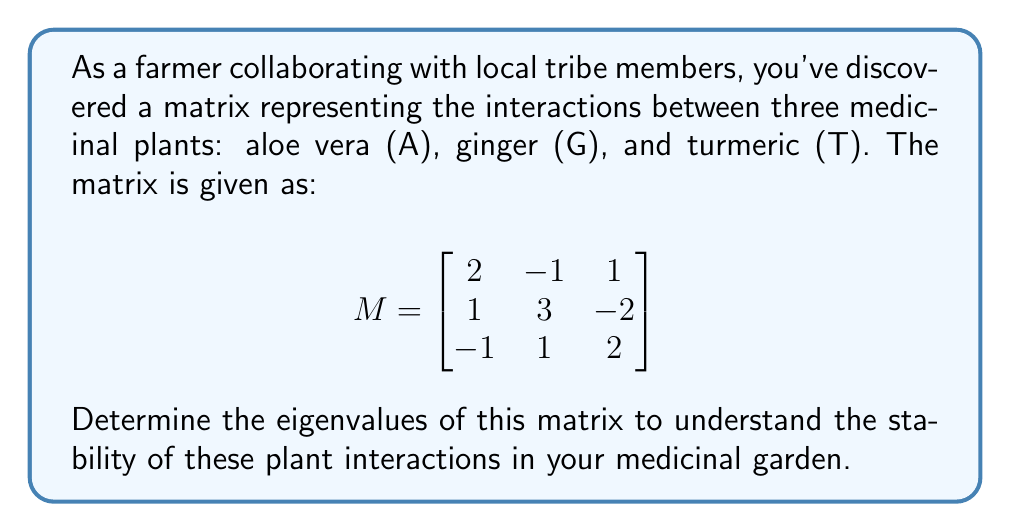Show me your answer to this math problem. To find the eigenvalues of matrix M, we need to solve the characteristic equation:

1. Set up the characteristic equation:
   $\det(M - \lambda I) = 0$, where $I$ is the 3x3 identity matrix and $\lambda$ represents the eigenvalues.

2. Expand the determinant:
   $$\det\begin{bmatrix}
   2-\lambda & -1 & 1 \\
   1 & 3-\lambda & -2 \\
   -1 & 1 & 2-\lambda
   \end{bmatrix} = 0$$

3. Calculate the determinant:
   $(2-\lambda)[(3-\lambda)(2-\lambda) - (-2)(1)] + (-1)[1(2-\lambda) - (-2)(-1)] + 1[1(1) - (3-\lambda)(-1)] = 0$

4. Simplify:
   $(2-\lambda)[(6-5\lambda+\lambda^2) + 2] + (-1)[2-\lambda+2] + 1[1+3-\lambda] = 0$
   $(2-\lambda)(8-5\lambda+\lambda^2) + (-1)(4-\lambda) + (4-\lambda) = 0$

5. Expand:
   $16-10\lambda+2\lambda^2-8\lambda+5\lambda^2-\lambda^3 = 0$
   $-\lambda^3 + 7\lambda^2 - 18\lambda + 16 = 0$

6. Factor the cubic equation:
   $-(\lambda - 1)(\lambda - 2)(\lambda - 4) = 0$

7. Solve for $\lambda$:
   $\lambda = 1, 2, 4$
Answer: $\lambda = 1, 2, 4$ 